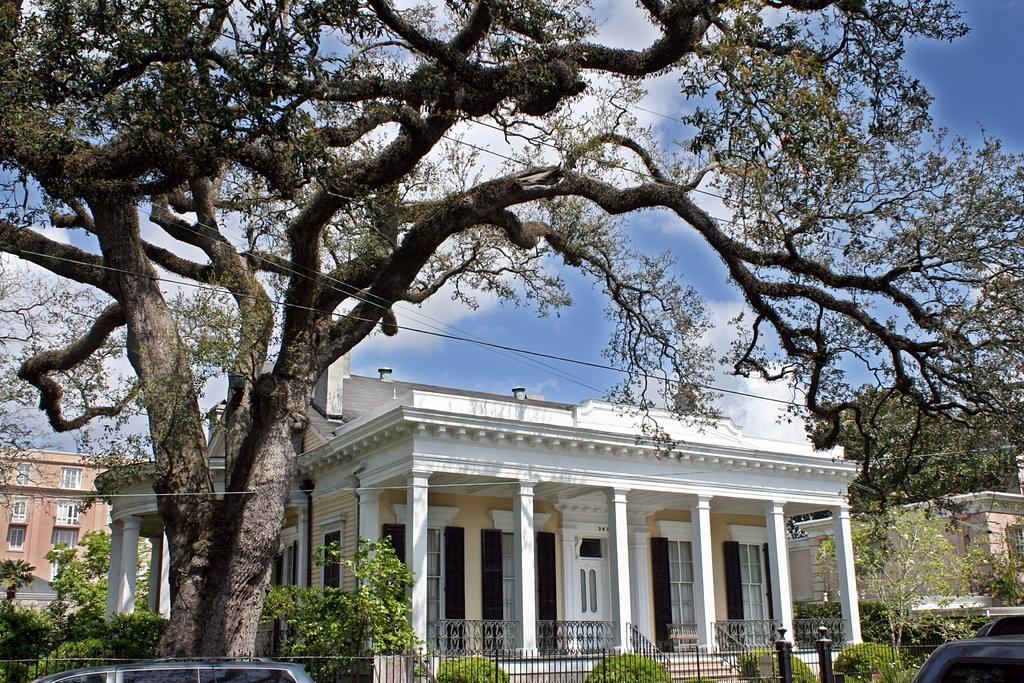In one or two sentences, can you explain what this image depicts? In this image we can see a few buildings and vehicles, there are some plants, trees, windows, poles, pillars, wires and fence, in the background we can see the sky. 